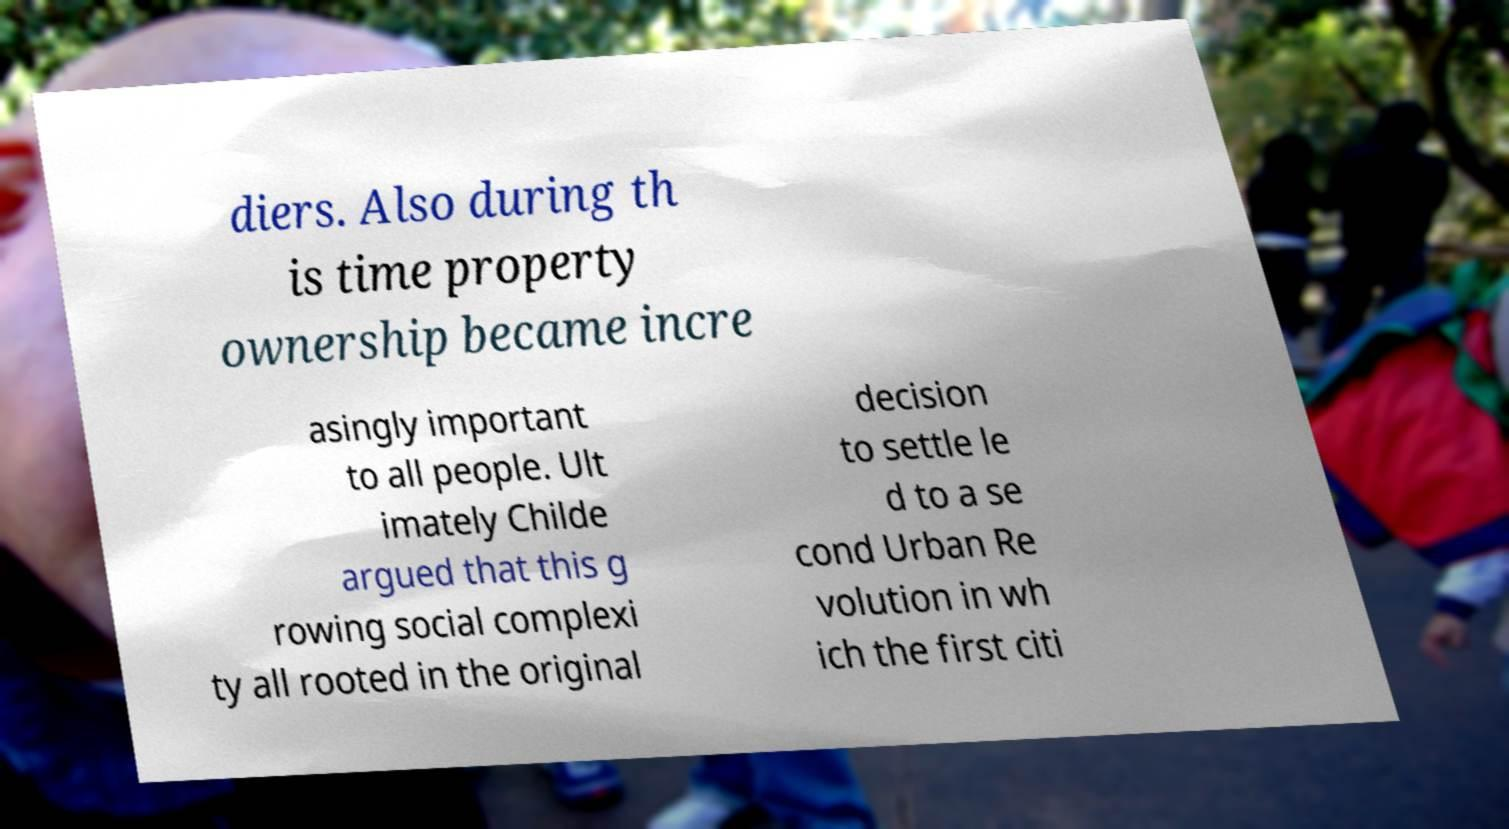I need the written content from this picture converted into text. Can you do that? diers. Also during th is time property ownership became incre asingly important to all people. Ult imately Childe argued that this g rowing social complexi ty all rooted in the original decision to settle le d to a se cond Urban Re volution in wh ich the first citi 